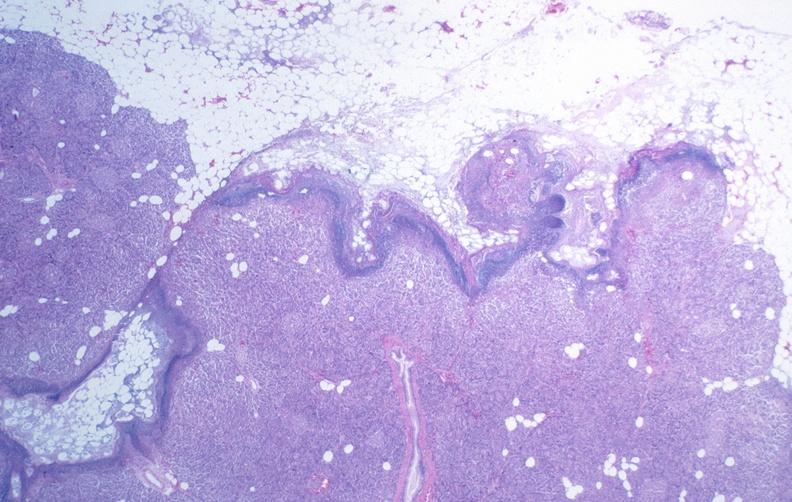does this image show pancreatic fat necrosis?
Answer the question using a single word or phrase. Yes 